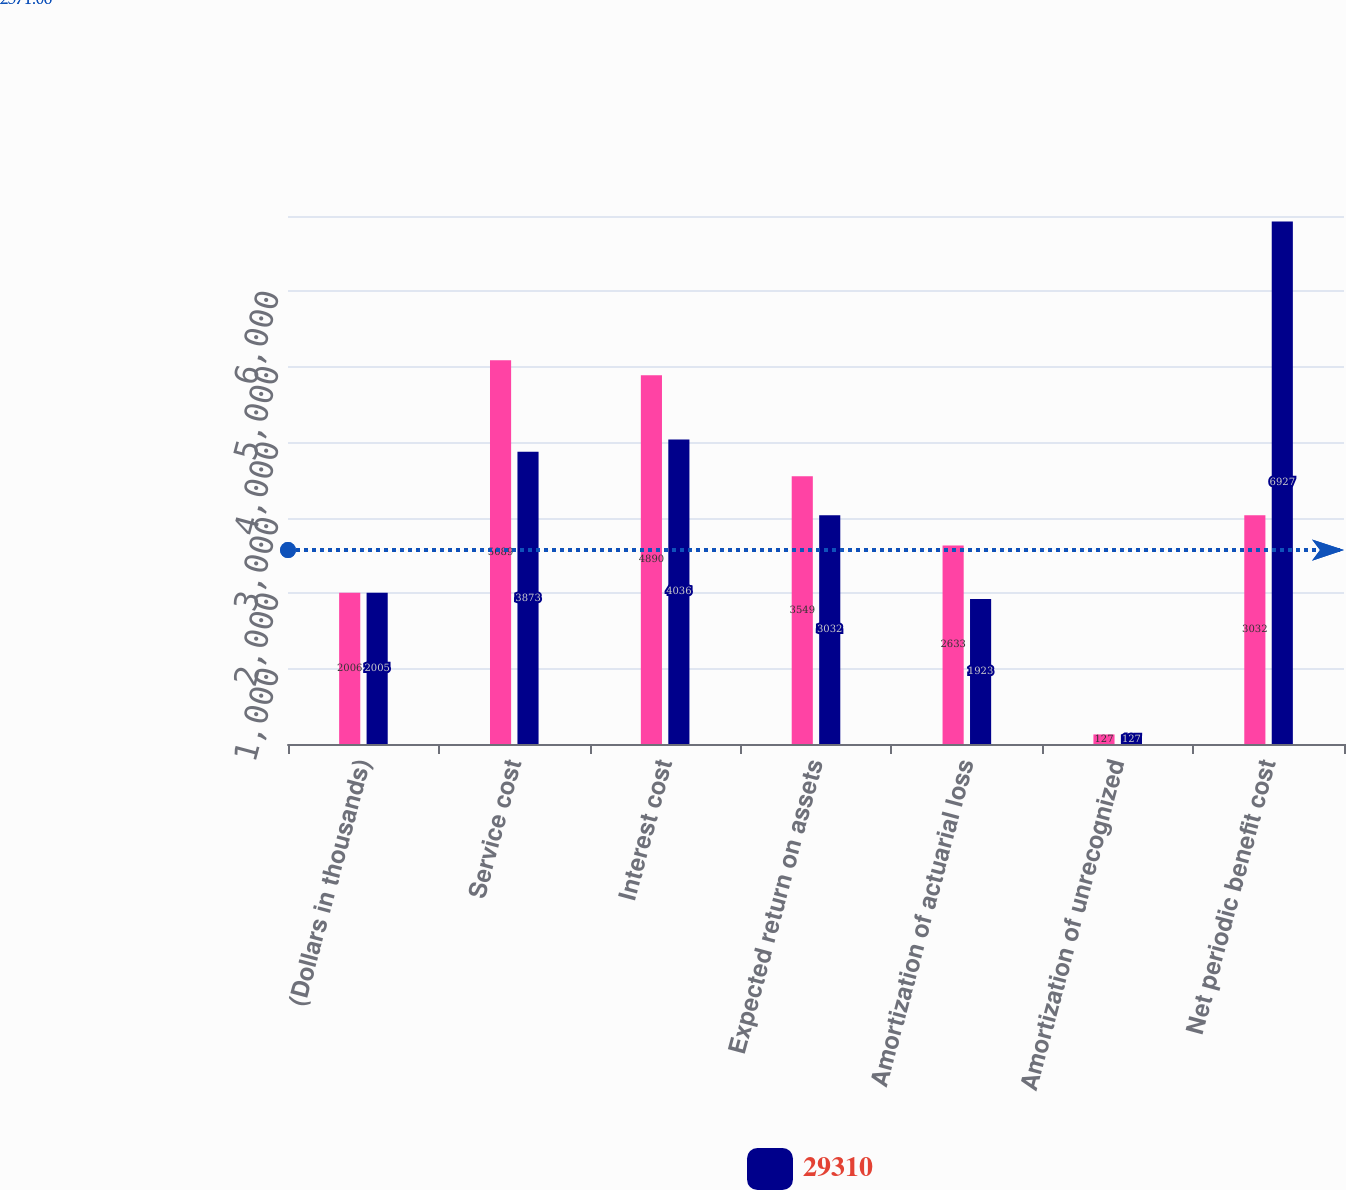<chart> <loc_0><loc_0><loc_500><loc_500><stacked_bar_chart><ecel><fcel>(Dollars in thousands)<fcel>Service cost<fcel>Interest cost<fcel>Expected return on assets<fcel>Amortization of actuarial loss<fcel>Amortization of unrecognized<fcel>Net periodic benefit cost<nl><fcel>nan<fcel>2006<fcel>5089<fcel>4890<fcel>3549<fcel>2633<fcel>127<fcel>3032<nl><fcel>29310<fcel>2005<fcel>3873<fcel>4036<fcel>3032<fcel>1923<fcel>127<fcel>6927<nl></chart> 